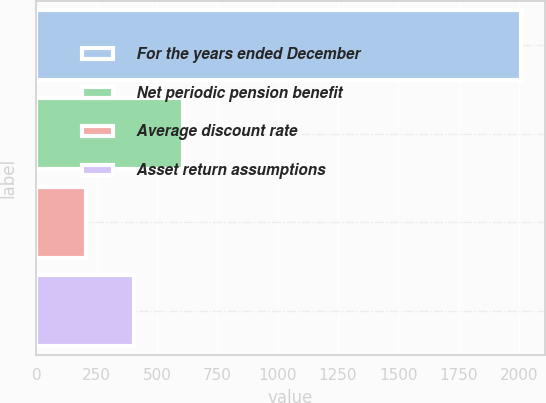<chart> <loc_0><loc_0><loc_500><loc_500><bar_chart><fcel>For the years ended December<fcel>Net periodic pension benefit<fcel>Average discount rate<fcel>Asset return assumptions<nl><fcel>2007<fcel>606.16<fcel>205.92<fcel>406.04<nl></chart> 